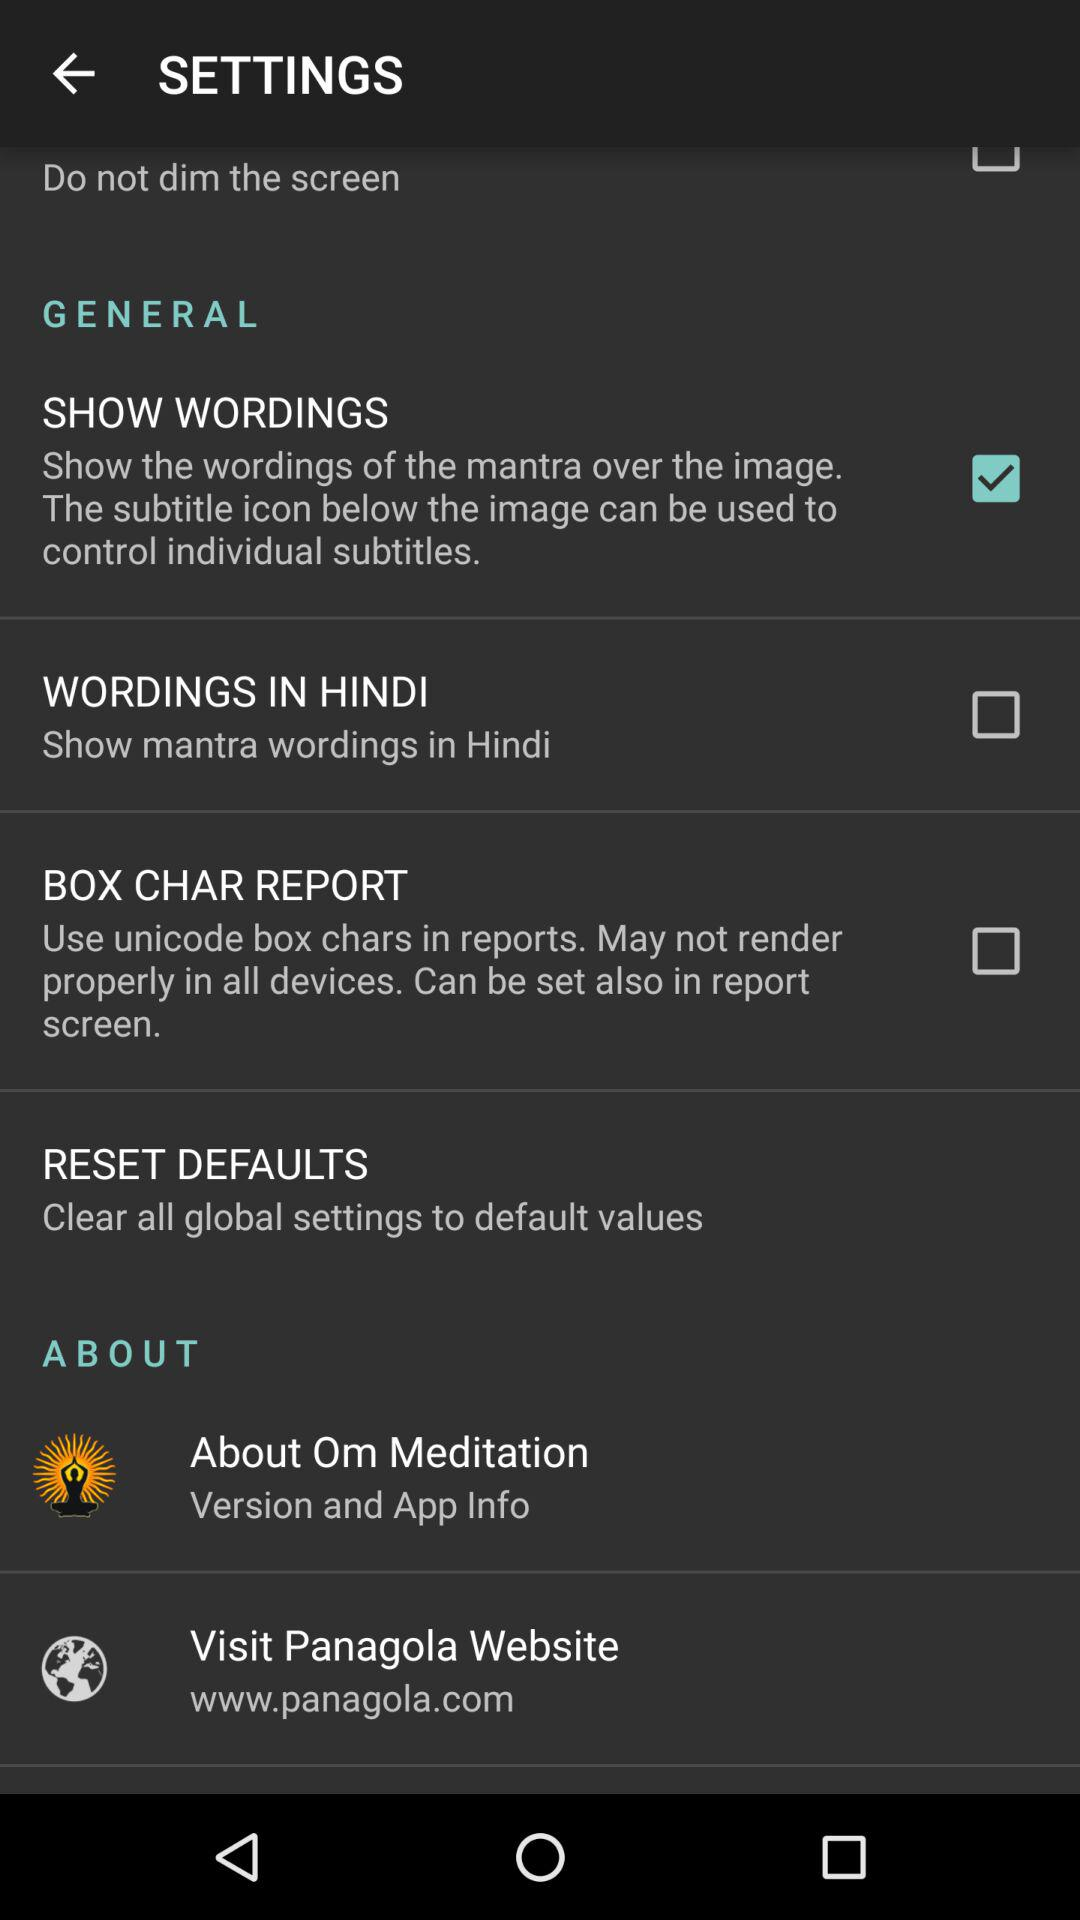What is the selected checkbox? The selected checkbox is "SHOW WORDINGS". 